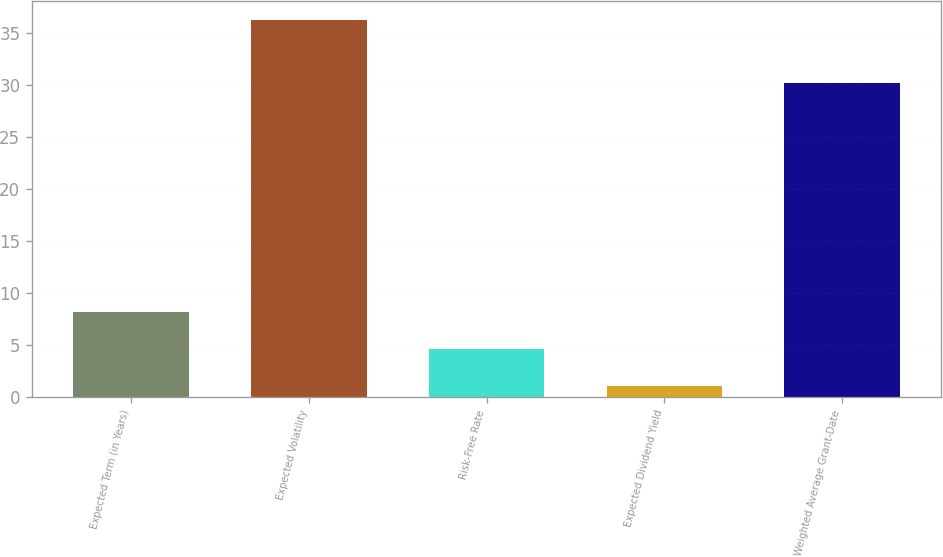Convert chart. <chart><loc_0><loc_0><loc_500><loc_500><bar_chart><fcel>Expected Term (in Years)<fcel>Expected Volatility<fcel>Risk-Free Rate<fcel>Expected Dividend Yield<fcel>Weighted Average Grant-Date<nl><fcel>8.12<fcel>36.2<fcel>4.61<fcel>1.1<fcel>30.17<nl></chart> 